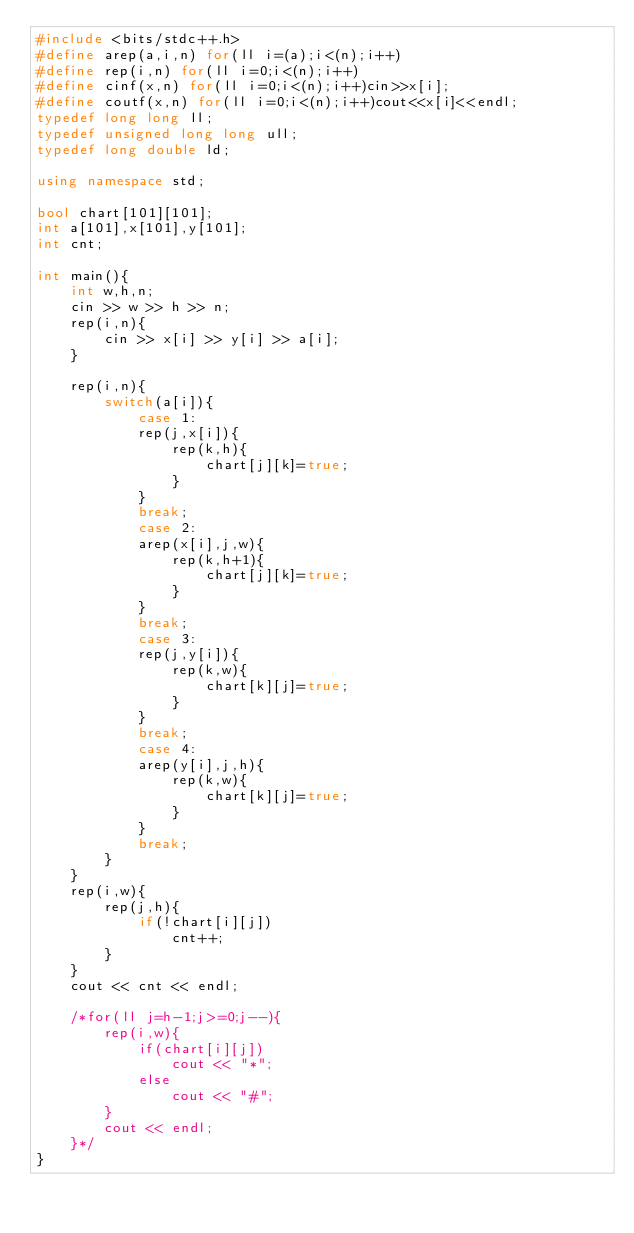Convert code to text. <code><loc_0><loc_0><loc_500><loc_500><_C++_>#include <bits/stdc++.h>
#define arep(a,i,n) for(ll i=(a);i<(n);i++)
#define rep(i,n) for(ll i=0;i<(n);i++)
#define cinf(x,n) for(ll i=0;i<(n);i++)cin>>x[i];
#define coutf(x,n) for(ll i=0;i<(n);i++)cout<<x[i]<<endl;
typedef long long ll;
typedef unsigned long long ull;
typedef long double ld;

using namespace std;

bool chart[101][101];
int a[101],x[101],y[101];
int cnt;

int main(){
	int w,h,n;
	cin >> w >> h >> n;
	rep(i,n){
		cin >> x[i] >> y[i] >> a[i];
	}

	rep(i,n){
		switch(a[i]){
			case 1:
			rep(j,x[i]){
				rep(k,h){
					chart[j][k]=true;
				}
			}
			break;
			case 2:
			arep(x[i],j,w){
				rep(k,h+1){
					chart[j][k]=true;
				}
			}
			break;
			case 3:
			rep(j,y[i]){
				rep(k,w){
					chart[k][j]=true;
				}
			}
			break;
			case 4:
			arep(y[i],j,h){
				rep(k,w){
					chart[k][j]=true;
				}
			}
			break;
		}
	}
	rep(i,w){
		rep(j,h){
			if(!chart[i][j])
				cnt++;
		}
	}
	cout << cnt << endl;

	/*for(ll j=h-1;j>=0;j--){
		rep(i,w){
			if(chart[i][j])
				cout << "*";
			else
				cout << "#";
		}
		cout << endl;
	}*/
}</code> 